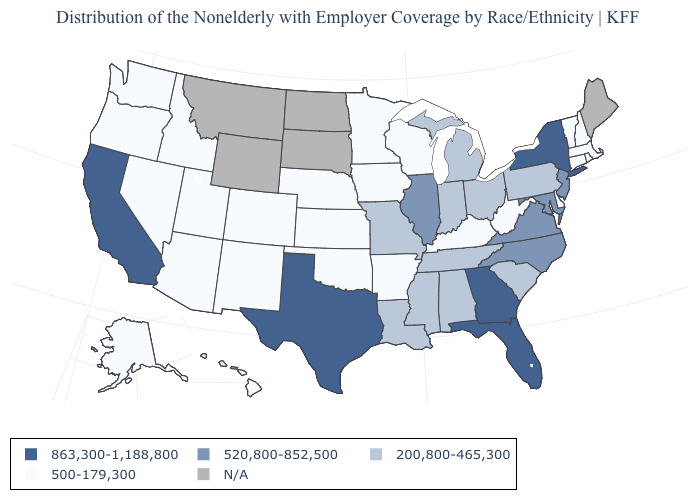Name the states that have a value in the range N/A?
Give a very brief answer. Maine, Montana, North Dakota, South Dakota, Wyoming. What is the value of California?
Answer briefly. 863,300-1,188,800. Among the states that border New Mexico , which have the lowest value?
Give a very brief answer. Arizona, Colorado, Oklahoma, Utah. What is the value of Nebraska?
Answer briefly. 500-179,300. What is the lowest value in the USA?
Concise answer only. 500-179,300. Does Georgia have the highest value in the South?
Short answer required. Yes. What is the lowest value in the USA?
Quick response, please. 500-179,300. Does South Carolina have the lowest value in the USA?
Short answer required. No. Name the states that have a value in the range N/A?
Give a very brief answer. Maine, Montana, North Dakota, South Dakota, Wyoming. Does the map have missing data?
Quick response, please. Yes. What is the lowest value in states that border California?
Write a very short answer. 500-179,300. Does the map have missing data?
Write a very short answer. Yes. What is the value of Wisconsin?
Keep it brief. 500-179,300. What is the lowest value in the USA?
Write a very short answer. 500-179,300. 